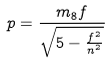<formula> <loc_0><loc_0><loc_500><loc_500>p = \frac { m _ { 8 } f } { \sqrt { 5 - \frac { f ^ { 2 } } { n ^ { 2 } } } }</formula> 